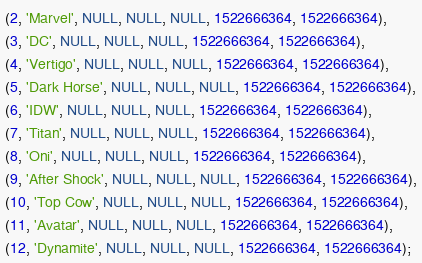Convert code to text. <code><loc_0><loc_0><loc_500><loc_500><_SQL_>(2, 'Marvel', NULL, NULL, NULL, 1522666364, 1522666364),
(3, 'DC', NULL, NULL, NULL, 1522666364, 1522666364),
(4, 'Vertigo', NULL, NULL, NULL, 1522666364, 1522666364),
(5, 'Dark Horse', NULL, NULL, NULL, 1522666364, 1522666364),
(6, 'IDW', NULL, NULL, NULL, 1522666364, 1522666364),
(7, 'Titan', NULL, NULL, NULL, 1522666364, 1522666364),
(8, 'Oni', NULL, NULL, NULL, 1522666364, 1522666364),
(9, 'After Shock', NULL, NULL, NULL, 1522666364, 1522666364),
(10, 'Top Cow', NULL, NULL, NULL, 1522666364, 1522666364),
(11, 'Avatar', NULL, NULL, NULL, 1522666364, 1522666364),
(12, 'Dynamite', NULL, NULL, NULL, 1522666364, 1522666364);
</code> 